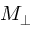<formula> <loc_0><loc_0><loc_500><loc_500>M _ { \perp }</formula> 